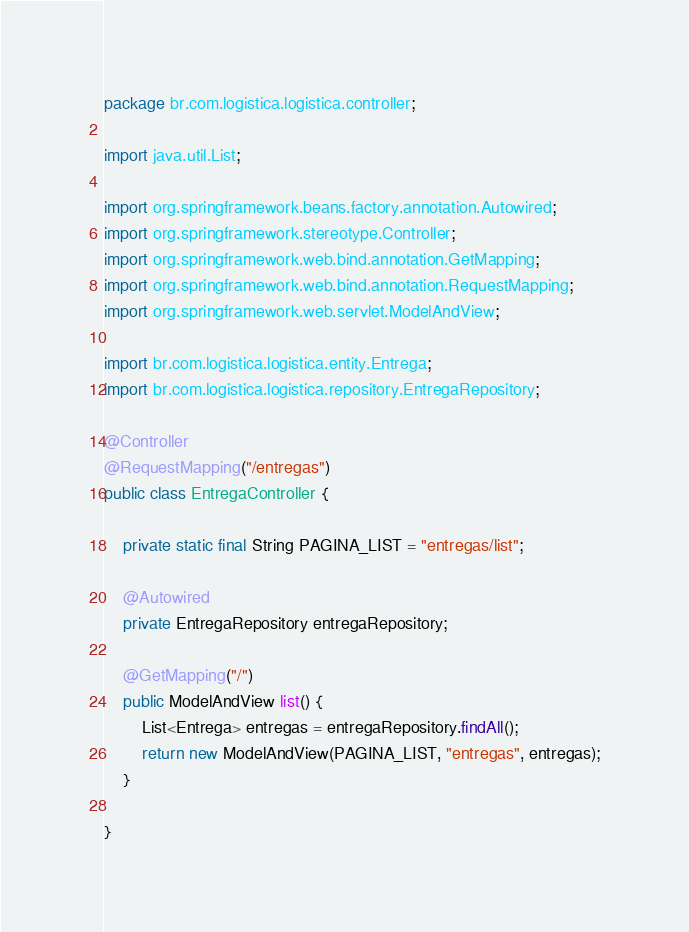Convert code to text. <code><loc_0><loc_0><loc_500><loc_500><_Java_>package br.com.logistica.logistica.controller;

import java.util.List;

import org.springframework.beans.factory.annotation.Autowired;
import org.springframework.stereotype.Controller;
import org.springframework.web.bind.annotation.GetMapping;
import org.springframework.web.bind.annotation.RequestMapping;
import org.springframework.web.servlet.ModelAndView;

import br.com.logistica.logistica.entity.Entrega;
import br.com.logistica.logistica.repository.EntregaRepository;

@Controller
@RequestMapping("/entregas")
public class EntregaController {
	
	private static final String PAGINA_LIST = "entregas/list";
	
	@Autowired
	private EntregaRepository entregaRepository;
	
	@GetMapping("/")
	public ModelAndView list() {
		List<Entrega> entregas = entregaRepository.findAll();
		return new ModelAndView(PAGINA_LIST, "entregas", entregas);
	}
	
}</code> 